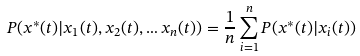Convert formula to latex. <formula><loc_0><loc_0><loc_500><loc_500>P ( x ^ { * } ( t ) | x _ { 1 } ( t ) , x _ { 2 } ( t ) , \dots x _ { n } ( t ) ) = \frac { 1 } { n } \sum _ { i = 1 } ^ { n } P ( x ^ { * } ( t ) | x _ { i } ( t ) )</formula> 